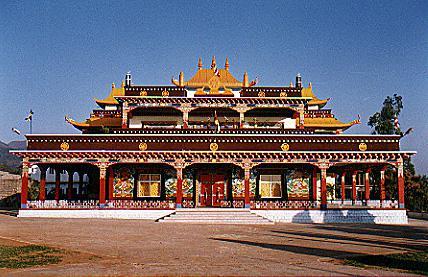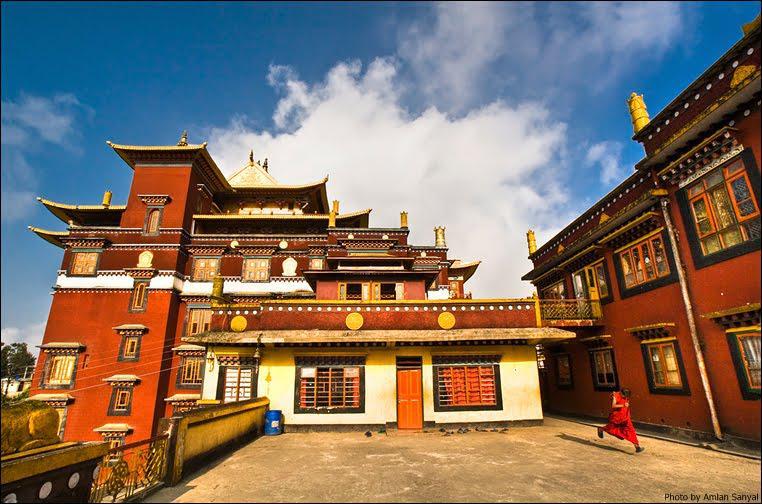The first image is the image on the left, the second image is the image on the right. For the images displayed, is the sentence "An image shows a temple with a line of red-bottomed columns along its front, and an empty lot in front of it." factually correct? Answer yes or no. Yes. The first image is the image on the left, the second image is the image on the right. Given the left and right images, does the statement "One building has gray stone material, the other does not." hold true? Answer yes or no. No. 